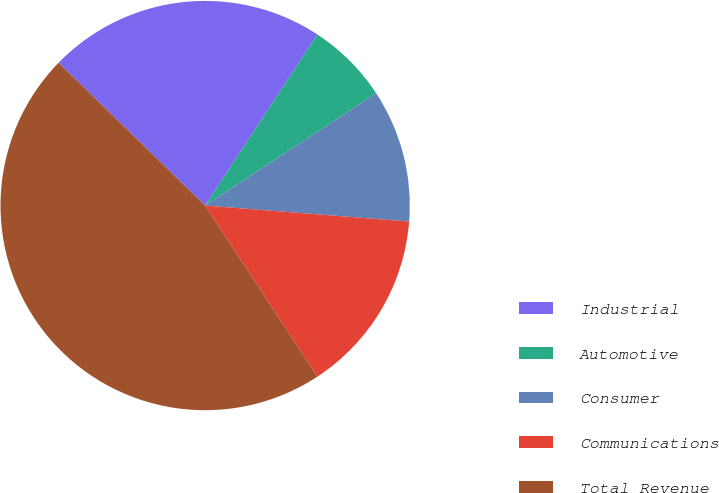Convert chart to OTSL. <chart><loc_0><loc_0><loc_500><loc_500><pie_chart><fcel>Industrial<fcel>Automotive<fcel>Consumer<fcel>Communications<fcel>Total Revenue<nl><fcel>21.95%<fcel>6.5%<fcel>10.5%<fcel>14.51%<fcel>46.54%<nl></chart> 